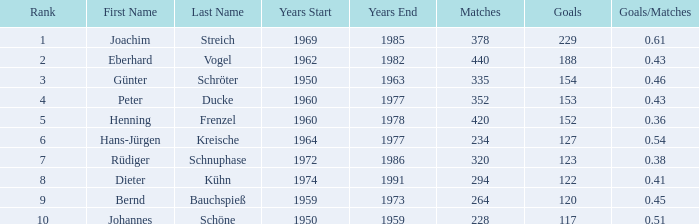What is the average number of goals in matches with less than 228 goals? None. 